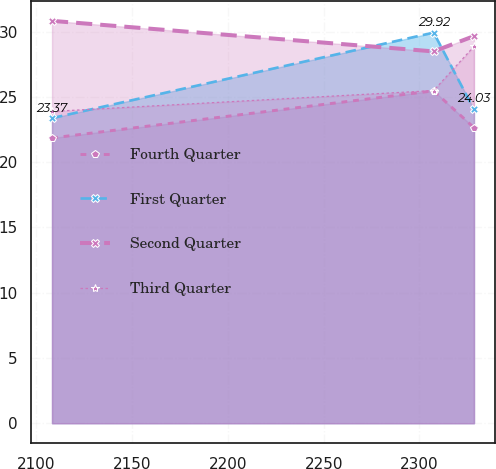<chart> <loc_0><loc_0><loc_500><loc_500><line_chart><ecel><fcel>Fourth Quarter<fcel>First Quarter<fcel>Second Quarter<fcel>Third Quarter<nl><fcel>2108.17<fcel>21.85<fcel>23.37<fcel>30.82<fcel>23.88<nl><fcel>2307.43<fcel>25.46<fcel>29.92<fcel>28.48<fcel>25.48<nl><fcel>2328.48<fcel>22.64<fcel>24.03<fcel>29.65<fcel>28.86<nl></chart> 